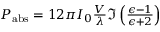Convert formula to latex. <formula><loc_0><loc_0><loc_500><loc_500>\begin{array} { r } { P _ { a b s } = 1 2 \pi I _ { 0 } \frac { V } { \lambda } \mathfrak { I } \left ( \frac { \epsilon - 1 } { \epsilon + 2 } \right ) } \end{array}</formula> 